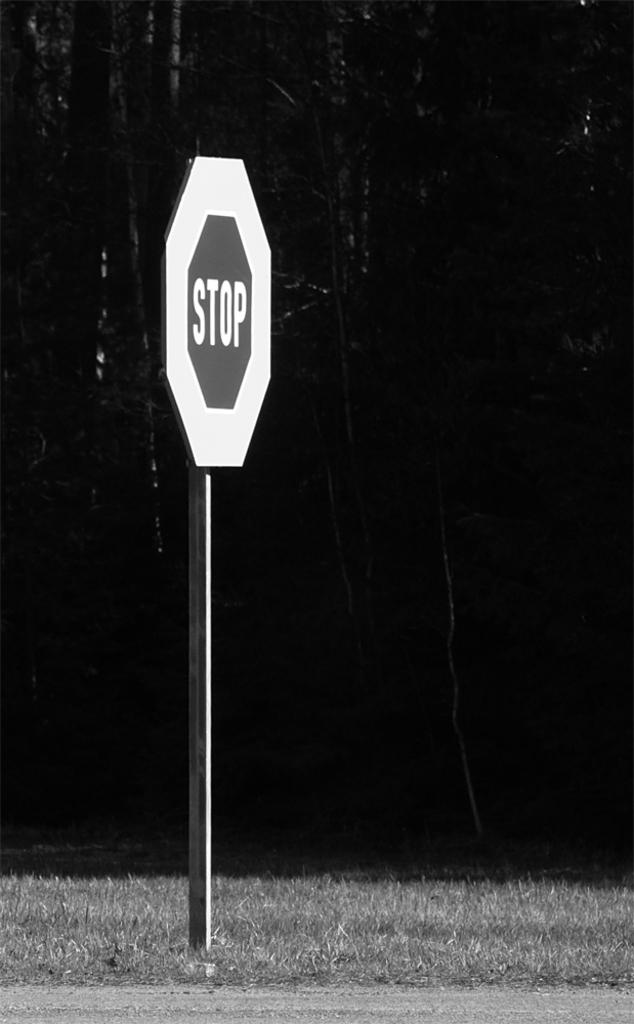<image>
Write a terse but informative summary of the picture. A stop sign with larger than usual border is stuck in the ground next to a road. 